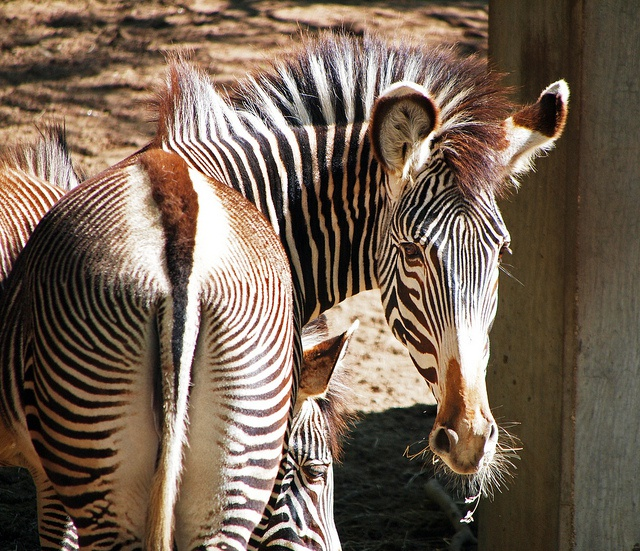Describe the objects in this image and their specific colors. I can see zebra in maroon, black, white, and gray tones and zebra in maroon, black, white, and brown tones in this image. 